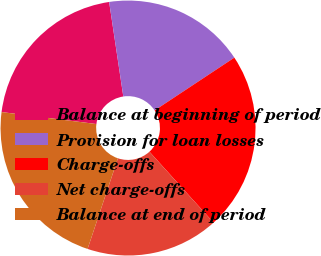Convert chart. <chart><loc_0><loc_0><loc_500><loc_500><pie_chart><fcel>Balance at beginning of period<fcel>Provision for loan losses<fcel>Charge-offs<fcel>Net charge-offs<fcel>Balance at end of period<nl><fcel>20.63%<fcel>18.06%<fcel>22.61%<fcel>16.84%<fcel>21.86%<nl></chart> 